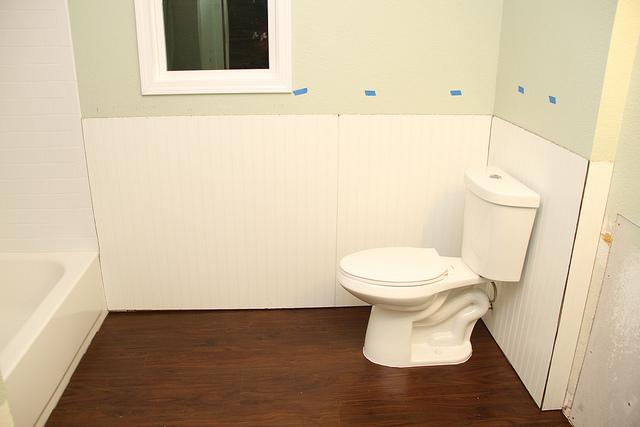Does this bathroom have a sink?
Short answer required. No. Is there anything other than a toilet in there?
Short answer required. Yes. Is the floor tile or wood?
Quick response, please. Wood. Is the tub full of water?
Quick response, please. No. Does the picture have a white brush in it?
Concise answer only. No. 